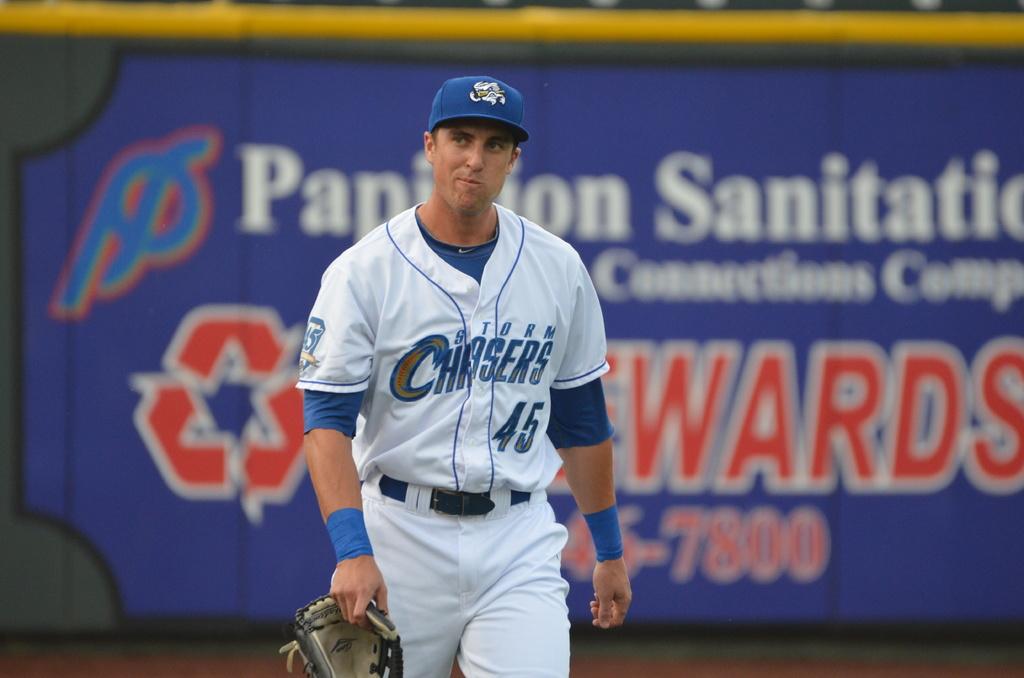What is the 4 digit number written in red?
Give a very brief answer. 7800. 